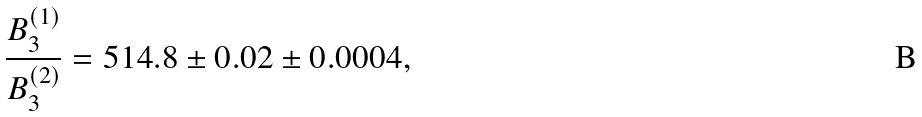Convert formula to latex. <formula><loc_0><loc_0><loc_500><loc_500>\frac { B _ { 3 } ^ { ( 1 ) } } { B _ { 3 } ^ { ( 2 ) } } = 5 1 4 . 8 \pm 0 . 0 2 \pm 0 . 0 0 0 4 ,</formula> 